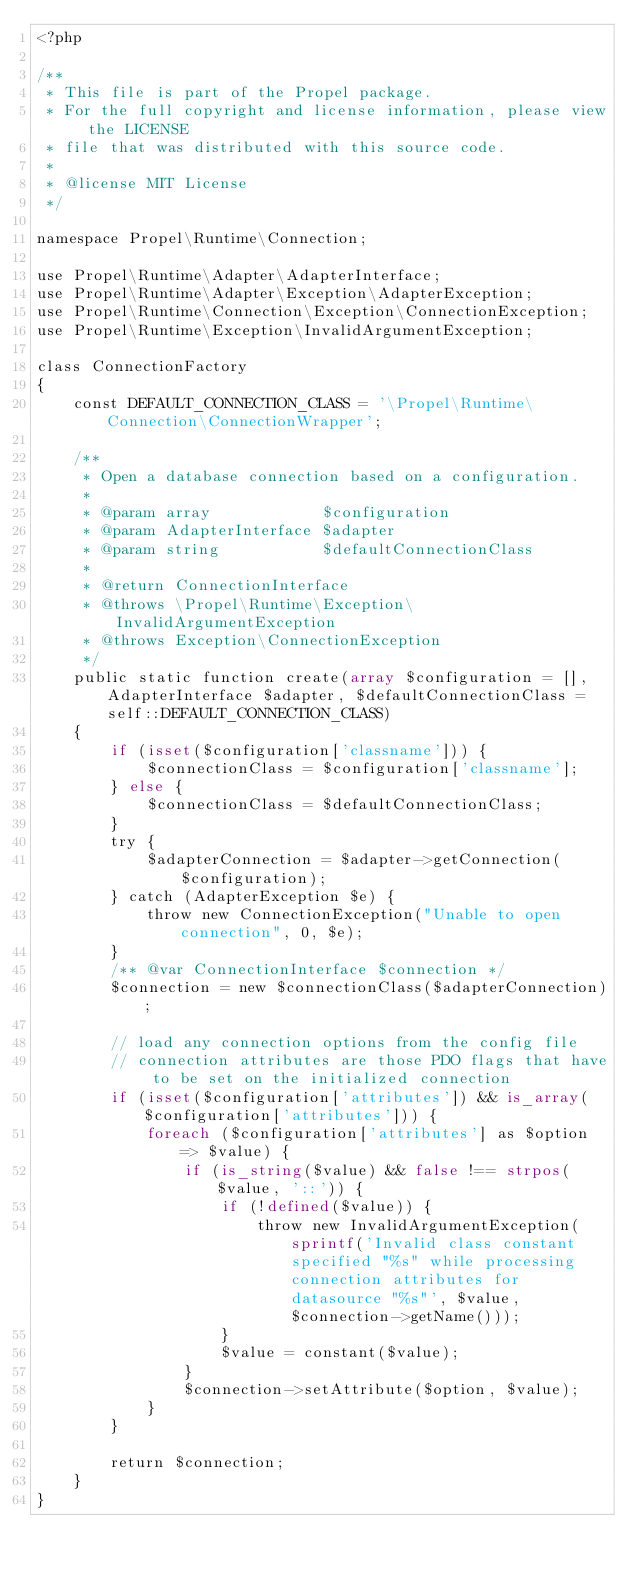Convert code to text. <code><loc_0><loc_0><loc_500><loc_500><_PHP_><?php

/**
 * This file is part of the Propel package.
 * For the full copyright and license information, please view the LICENSE
 * file that was distributed with this source code.
 *
 * @license MIT License
 */

namespace Propel\Runtime\Connection;

use Propel\Runtime\Adapter\AdapterInterface;
use Propel\Runtime\Adapter\Exception\AdapterException;
use Propel\Runtime\Connection\Exception\ConnectionException;
use Propel\Runtime\Exception\InvalidArgumentException;

class ConnectionFactory
{
    const DEFAULT_CONNECTION_CLASS = '\Propel\Runtime\Connection\ConnectionWrapper';

    /**
     * Open a database connection based on a configuration.
     *
     * @param array            $configuration
     * @param AdapterInterface $adapter
     * @param string           $defaultConnectionClass
     *
     * @return ConnectionInterface
     * @throws \Propel\Runtime\Exception\InvalidArgumentException
     * @throws Exception\ConnectionException
     */
    public static function create(array $configuration = [], AdapterInterface $adapter, $defaultConnectionClass = self::DEFAULT_CONNECTION_CLASS)
    {
        if (isset($configuration['classname'])) {
            $connectionClass = $configuration['classname'];
        } else {
            $connectionClass = $defaultConnectionClass;
        }
        try {
            $adapterConnection = $adapter->getConnection($configuration);
        } catch (AdapterException $e) {
            throw new ConnectionException("Unable to open connection", 0, $e);
        }
        /** @var ConnectionInterface $connection */
        $connection = new $connectionClass($adapterConnection);

        // load any connection options from the config file
        // connection attributes are those PDO flags that have to be set on the initialized connection
        if (isset($configuration['attributes']) && is_array($configuration['attributes'])) {
            foreach ($configuration['attributes'] as $option => $value) {
                if (is_string($value) && false !== strpos($value, '::')) {
                    if (!defined($value)) {
                        throw new InvalidArgumentException(sprintf('Invalid class constant specified "%s" while processing connection attributes for datasource "%s"', $value, $connection->getName()));
                    }
                    $value = constant($value);
                }
                $connection->setAttribute($option, $value);
            }
        }

        return $connection;
    }
}
</code> 